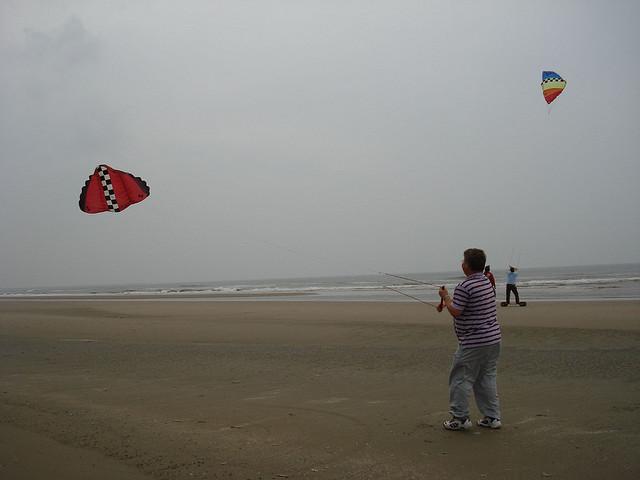Does this person need to lose weight?
Concise answer only. Yes. How many kites are there?
Answer briefly. 2. What does the kite look like?
Answer briefly. Racecar. What color are the women pants?
Be succinct. Gray. How many kites have a checkered pattern?
Write a very short answer. 2. Why is this a popular location for this activity?
Be succinct. Spacious. What kind of suit is the man wearing?
Give a very brief answer. None. How many people are holding onto the parachute line?
Quick response, please. 1. 